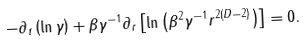Convert formula to latex. <formula><loc_0><loc_0><loc_500><loc_500>- \partial _ { t } \left ( \ln \gamma \right ) + \beta \gamma ^ { - 1 } \partial _ { r } \left [ \ln \left ( \beta ^ { 2 } \gamma ^ { - 1 } r ^ { 2 ( D - 2 ) } \right ) \right ] = 0 .</formula> 